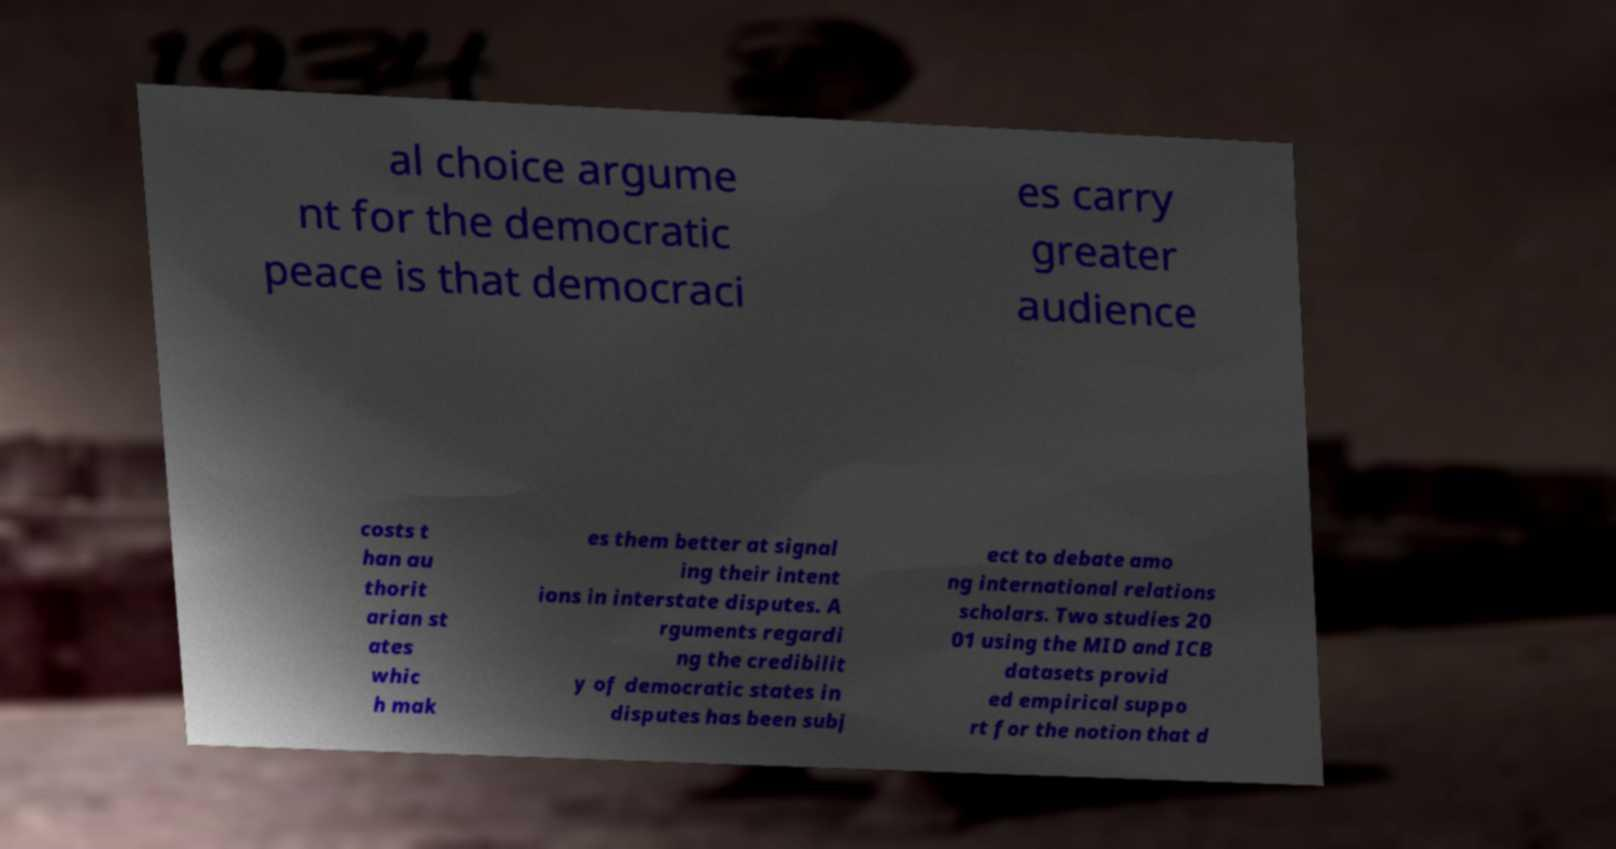There's text embedded in this image that I need extracted. Can you transcribe it verbatim? al choice argume nt for the democratic peace is that democraci es carry greater audience costs t han au thorit arian st ates whic h mak es them better at signal ing their intent ions in interstate disputes. A rguments regardi ng the credibilit y of democratic states in disputes has been subj ect to debate amo ng international relations scholars. Two studies 20 01 using the MID and ICB datasets provid ed empirical suppo rt for the notion that d 